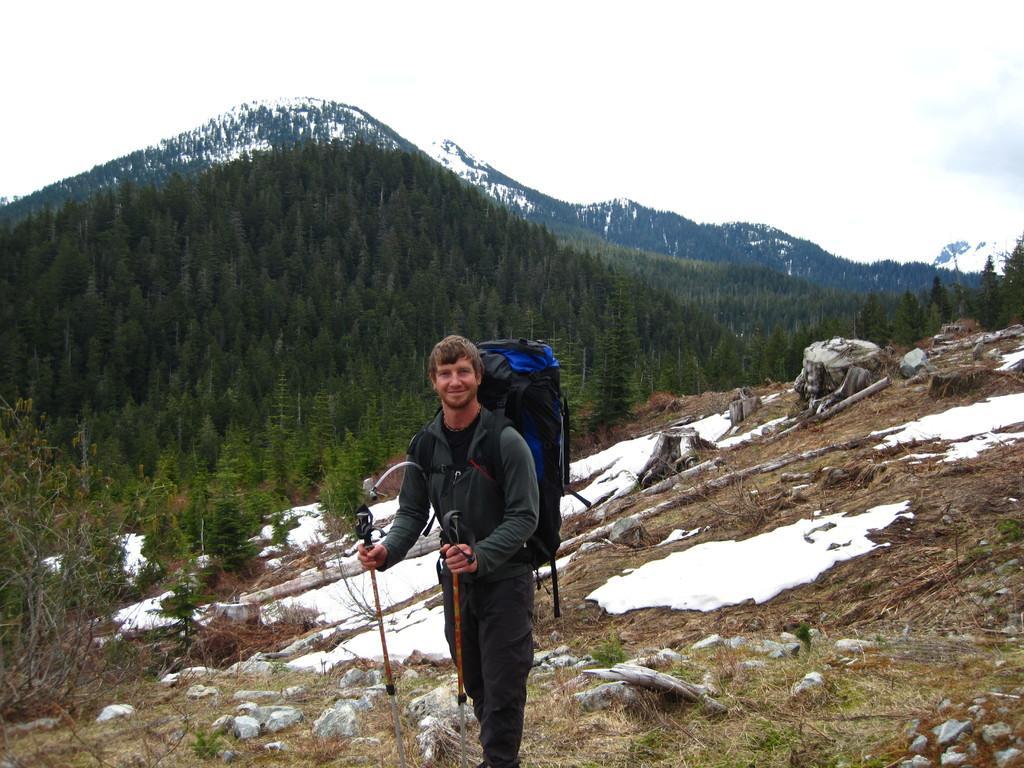Please provide a concise description of this image. In this image we can see a man standing on the ground by wearing a backpack and holding walking sticks in the hands. In the background there are plants, trees, mountains and sky. 